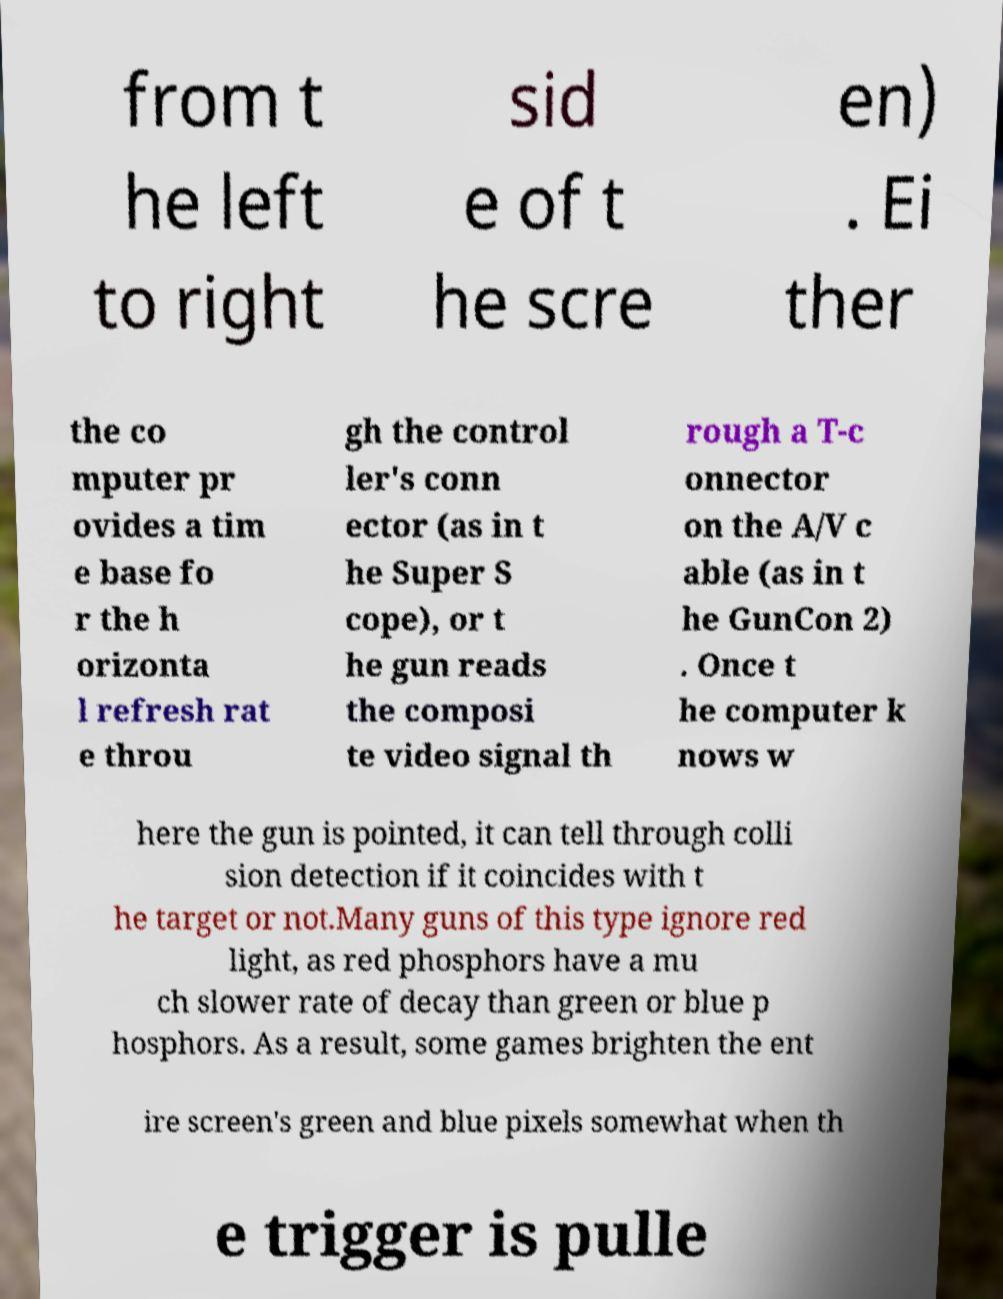Please read and relay the text visible in this image. What does it say? from t he left to right sid e of t he scre en) . Ei ther the co mputer pr ovides a tim e base fo r the h orizonta l refresh rat e throu gh the control ler's conn ector (as in t he Super S cope), or t he gun reads the composi te video signal th rough a T-c onnector on the A/V c able (as in t he GunCon 2) . Once t he computer k nows w here the gun is pointed, it can tell through colli sion detection if it coincides with t he target or not.Many guns of this type ignore red light, as red phosphors have a mu ch slower rate of decay than green or blue p hosphors. As a result, some games brighten the ent ire screen's green and blue pixels somewhat when th e trigger is pulle 